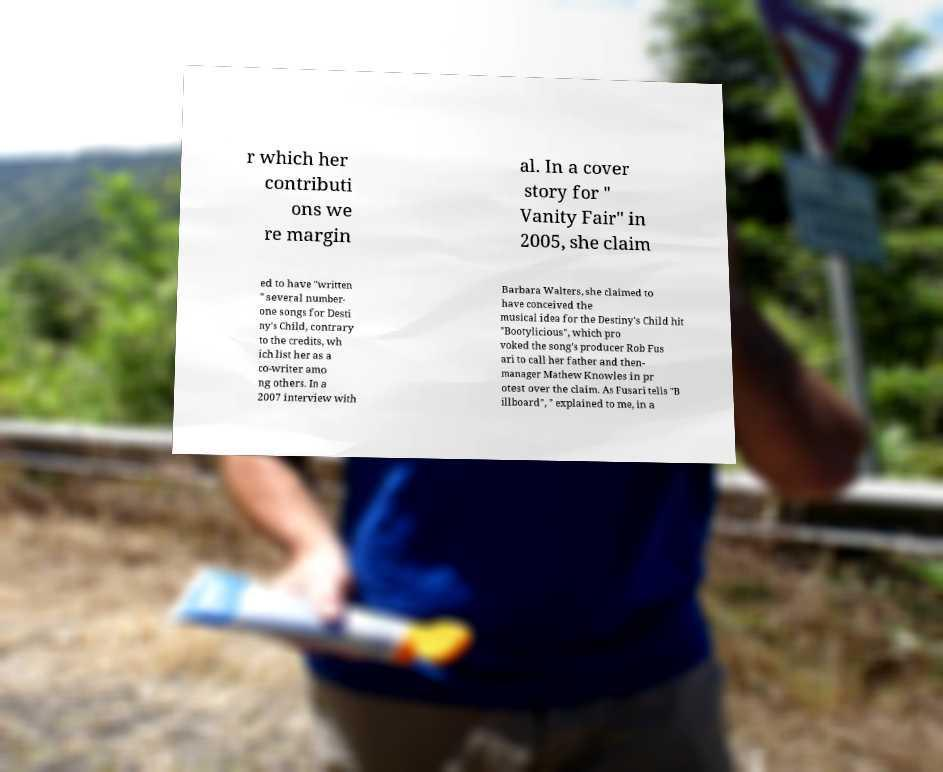For documentation purposes, I need the text within this image transcribed. Could you provide that? r which her contributi ons we re margin al. In a cover story for " Vanity Fair" in 2005, she claim ed to have "written " several number- one songs for Desti ny's Child, contrary to the credits, wh ich list her as a co-writer amo ng others. In a 2007 interview with Barbara Walters, she claimed to have conceived the musical idea for the Destiny's Child hit "Bootylicious", which pro voked the song's producer Rob Fus ari to call her father and then- manager Mathew Knowles in pr otest over the claim. As Fusari tells "B illboard", " explained to me, in a 